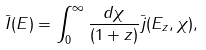<formula> <loc_0><loc_0><loc_500><loc_500>\bar { I } ( E ) = \int _ { 0 } ^ { \infty } \frac { d \chi } { ( 1 + z ) } \bar { j } ( E _ { z } , \chi ) ,</formula> 